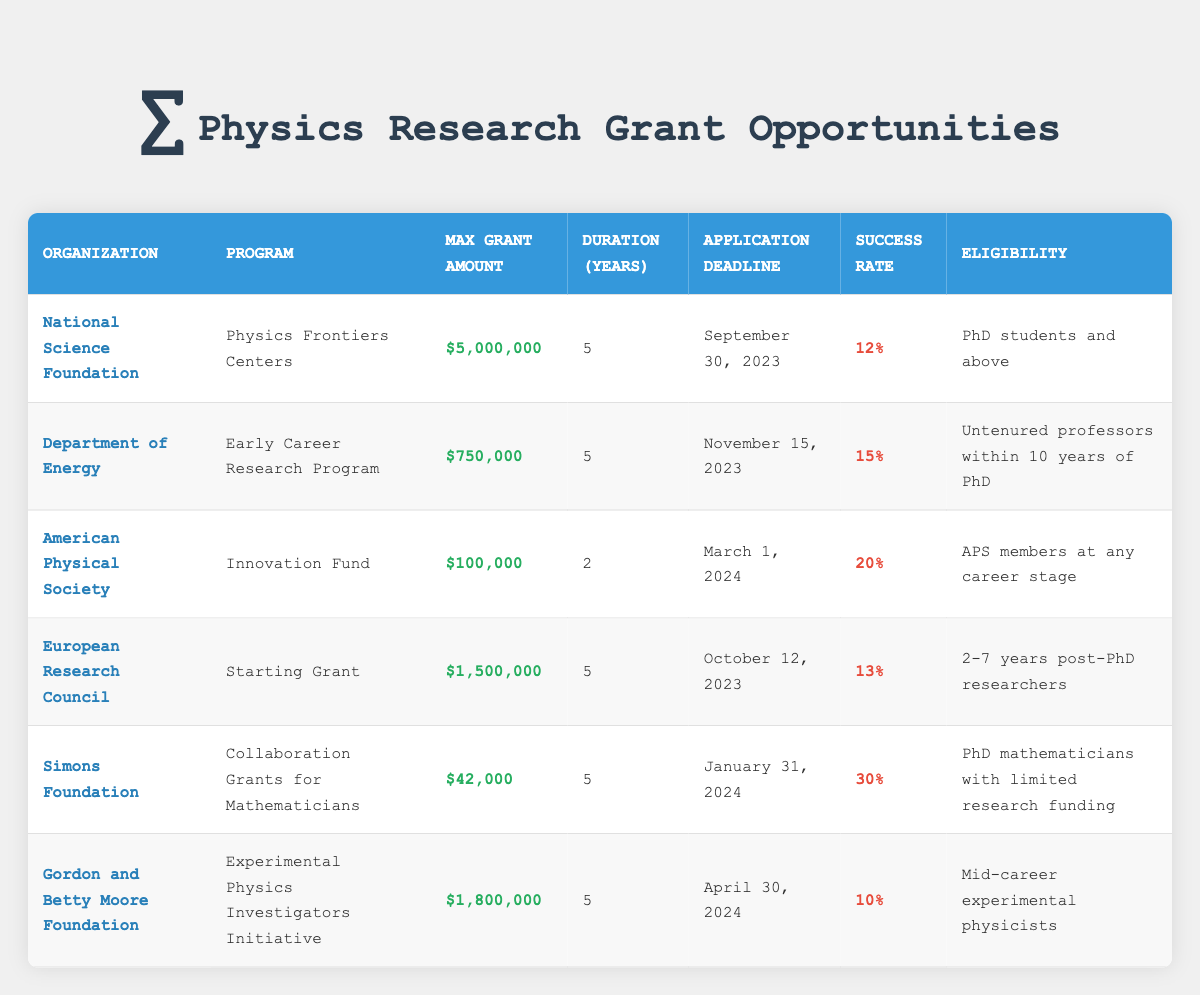What is the maximum grant amount offered by the National Science Foundation? The table shows that the maximum grant amount for the National Science Foundation under the Physics Frontiers Centers program is listed directly in the corresponding row. It states "$5,000,000" as the max grant amount.
Answer: $5,000,000 Which program has the highest success rate? To find the program with the highest success rate, we must compare the success rates listed for each funding opportunity: 12%, 15%, 20%, 13%, 30%, and 10%. The highest of these values is 30%, which corresponds to the Simons Foundation program for Collaboration Grants for Mathematicians.
Answer: Collaboration Grants for Mathematicians Is the application deadline for the Early Career Research Program before the application deadline for the Innovation Fund? The application deadlines for both programs are listed in the table. The Early Career Research Program has a deadline of November 15, 2023, while the Innovation Fund's deadline is March 1, 2024. Since November is before March, the statement is true.
Answer: Yes What is the average max grant amount for all listed funding opportunities? To calculate the average max grant amount, we first sum all the listed amounts: $5,000,000 + $750,000 + $100,000 + $1,500,000 + $42,000 + $1,800,000 = $9,192,000. Then, we divide this sum by the number of programs, which is 6. So, the average max grant amount is $9,192,000 / 6 = $1,532,000.
Answer: $1,532,000 Are there any funding opportunities with a maximum grant amount exceeding $1,000,000? By looking at the max grant amounts, we see that the National Science Foundation ($5,000,000), the European Research Council ($1,500,000), and the Gordon and Betty Moore Foundation ($1,800,000) all exceed $1,000,000. Therefore, the answer is true since there are multiple opportunities with such amounts.
Answer: Yes What is the eligibility criterion for the American Physical Society's Innovation Fund? The table states that the eligibility criterion for the American Physical Society's Innovation Fund is "APS members at any career stage." This information is directly taken from the eligibility column in the corresponding row of the table.
Answer: APS members at any career stage How many programs have a duration of 5 years? To find this, we can inspect the duration column for each program and count how many entries have "5" years. In the table, the programs with a 5-year duration are: Physics Frontiers Centers, Early Career Research Program, Starting Grant, Collaboration Grants for Mathematicians, and Experimental Physics Investigators Initiative. This totals to 5 programs.
Answer: 5 Which organization offers a fund for PhD students and above? Referring to the eligibility criteria, the National Science Foundation's program, Physics Frontiers Centers, specifies that it is available for "PhD students and above." This information is found in the eligibility column for that row.
Answer: National Science Foundation 